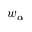Convert formula to latex. <formula><loc_0><loc_0><loc_500><loc_500>w _ { \alpha }</formula> 